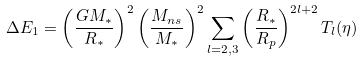Convert formula to latex. <formula><loc_0><loc_0><loc_500><loc_500>\Delta E _ { 1 } = \left ( \frac { G M _ { \ast } } { R _ { \ast } } \right ) ^ { 2 } \left ( \frac { M _ { n s } } { M _ { \ast } } \right ) ^ { 2 } \sum _ { l = 2 , 3 } \left ( \frac { R _ { \ast } } { R _ { p } } \right ) ^ { 2 l + 2 } T _ { l } ( \eta )</formula> 